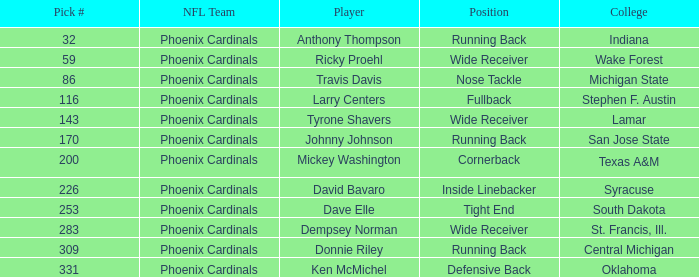What is the choice number from south dakota college? 253.0. 